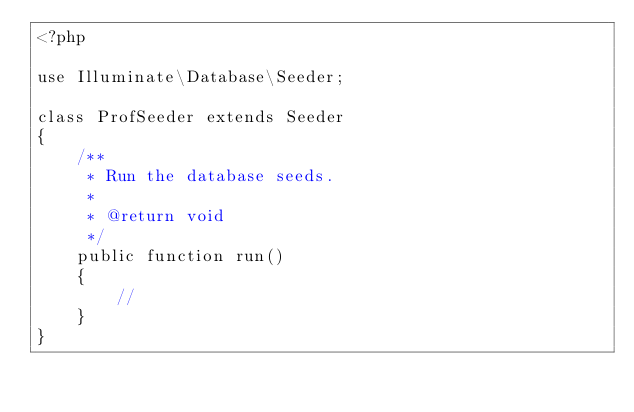Convert code to text. <code><loc_0><loc_0><loc_500><loc_500><_PHP_><?php

use Illuminate\Database\Seeder;

class ProfSeeder extends Seeder
{
    /**
     * Run the database seeds.
     *
     * @return void
     */
    public function run()
    {
        //
    }
}
</code> 